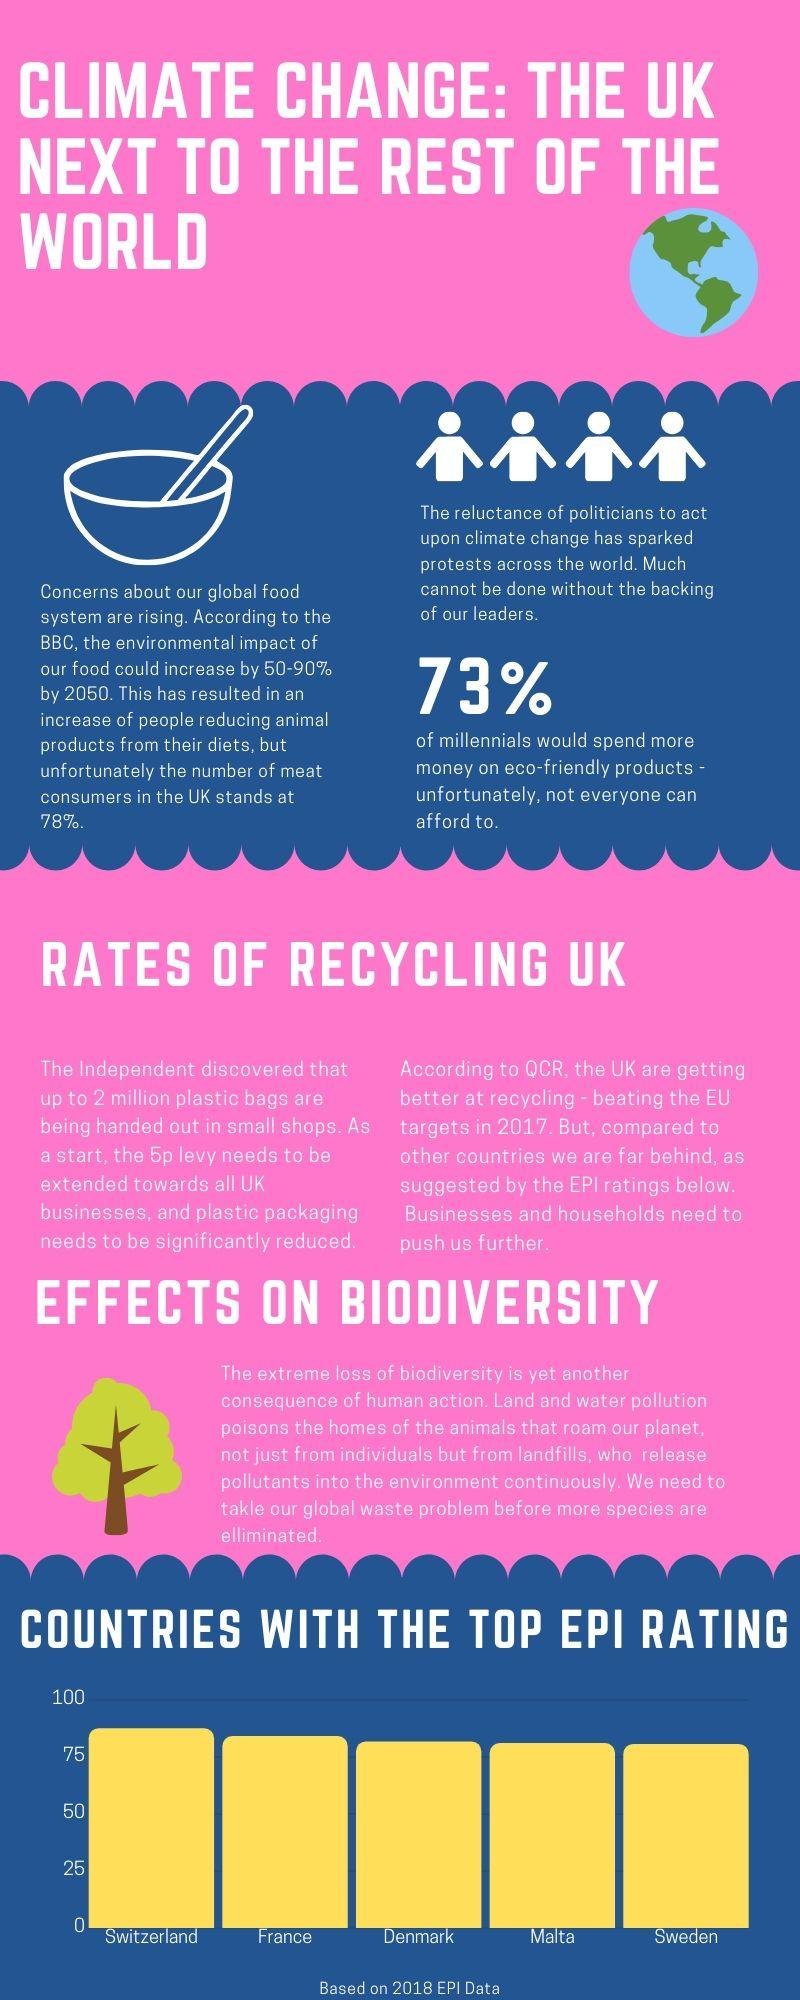Give some essential details in this illustration. Malta ranks fourth in the top EPI rating based on 2018 data. According to a recent survey, nearly a quarter of people in the UK do not consume meat. According to a recent survey, 27% of millennials stated that they cannot afford eco-friendly products. 